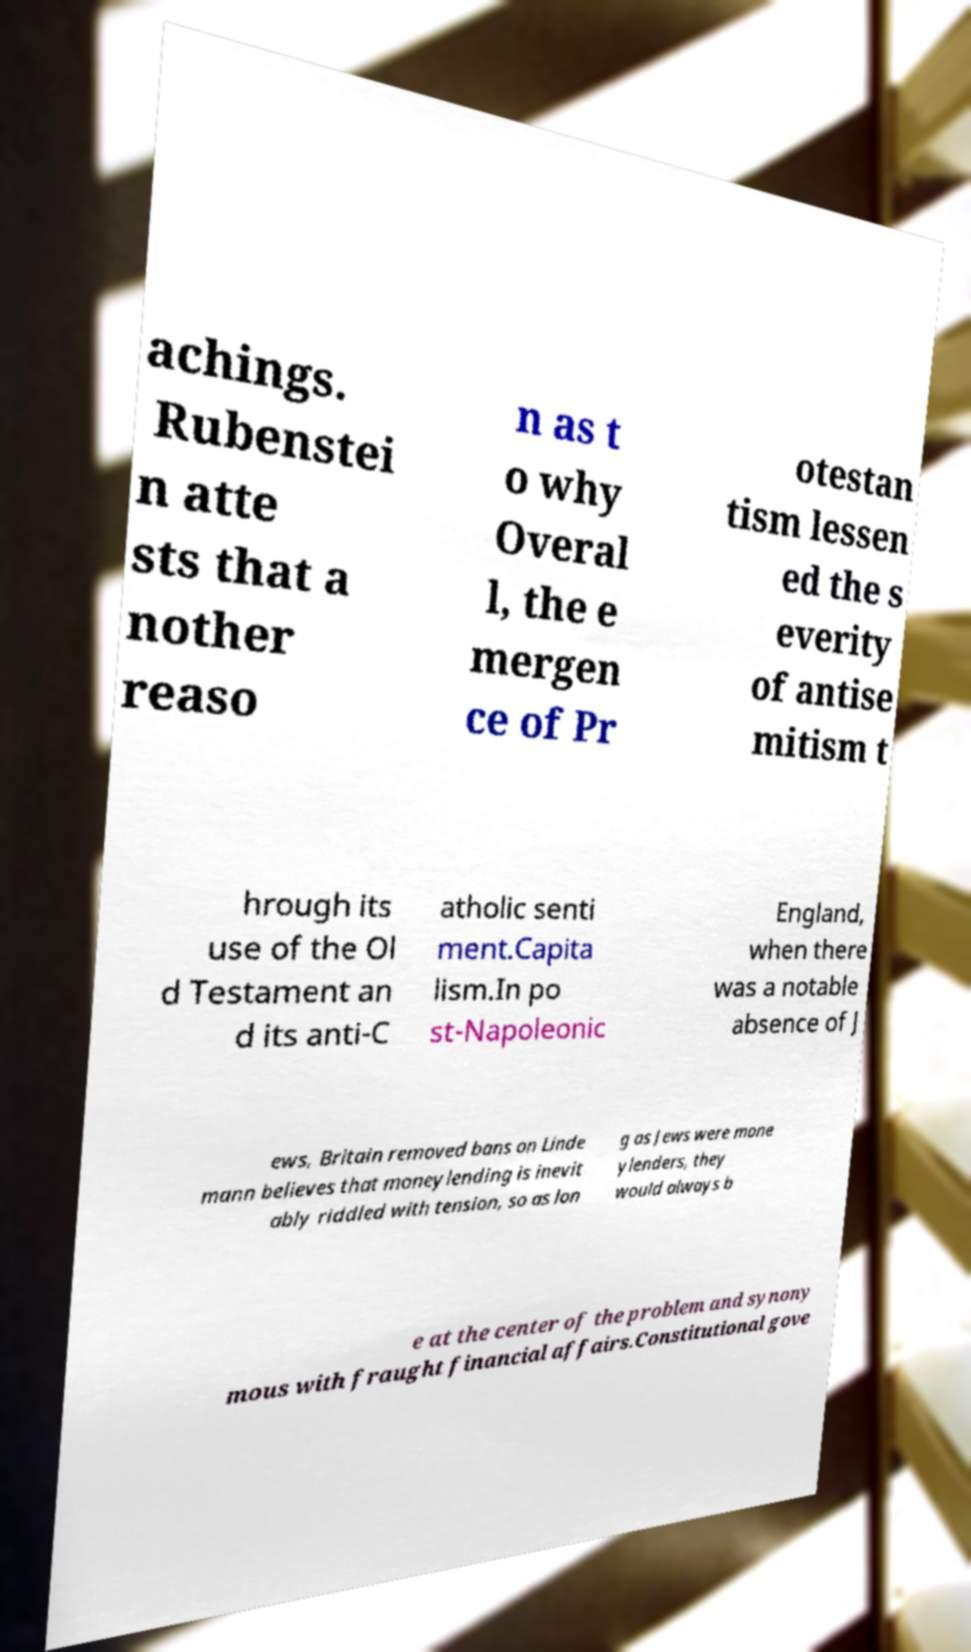Could you extract and type out the text from this image? achings. Rubenstei n atte sts that a nother reaso n as t o why Overal l, the e mergen ce of Pr otestan tism lessen ed the s everity of antise mitism t hrough its use of the Ol d Testament an d its anti-C atholic senti ment.Capita lism.In po st-Napoleonic England, when there was a notable absence of J ews, Britain removed bans on Linde mann believes that moneylending is inevit ably riddled with tension, so as lon g as Jews were mone ylenders, they would always b e at the center of the problem and synony mous with fraught financial affairs.Constitutional gove 